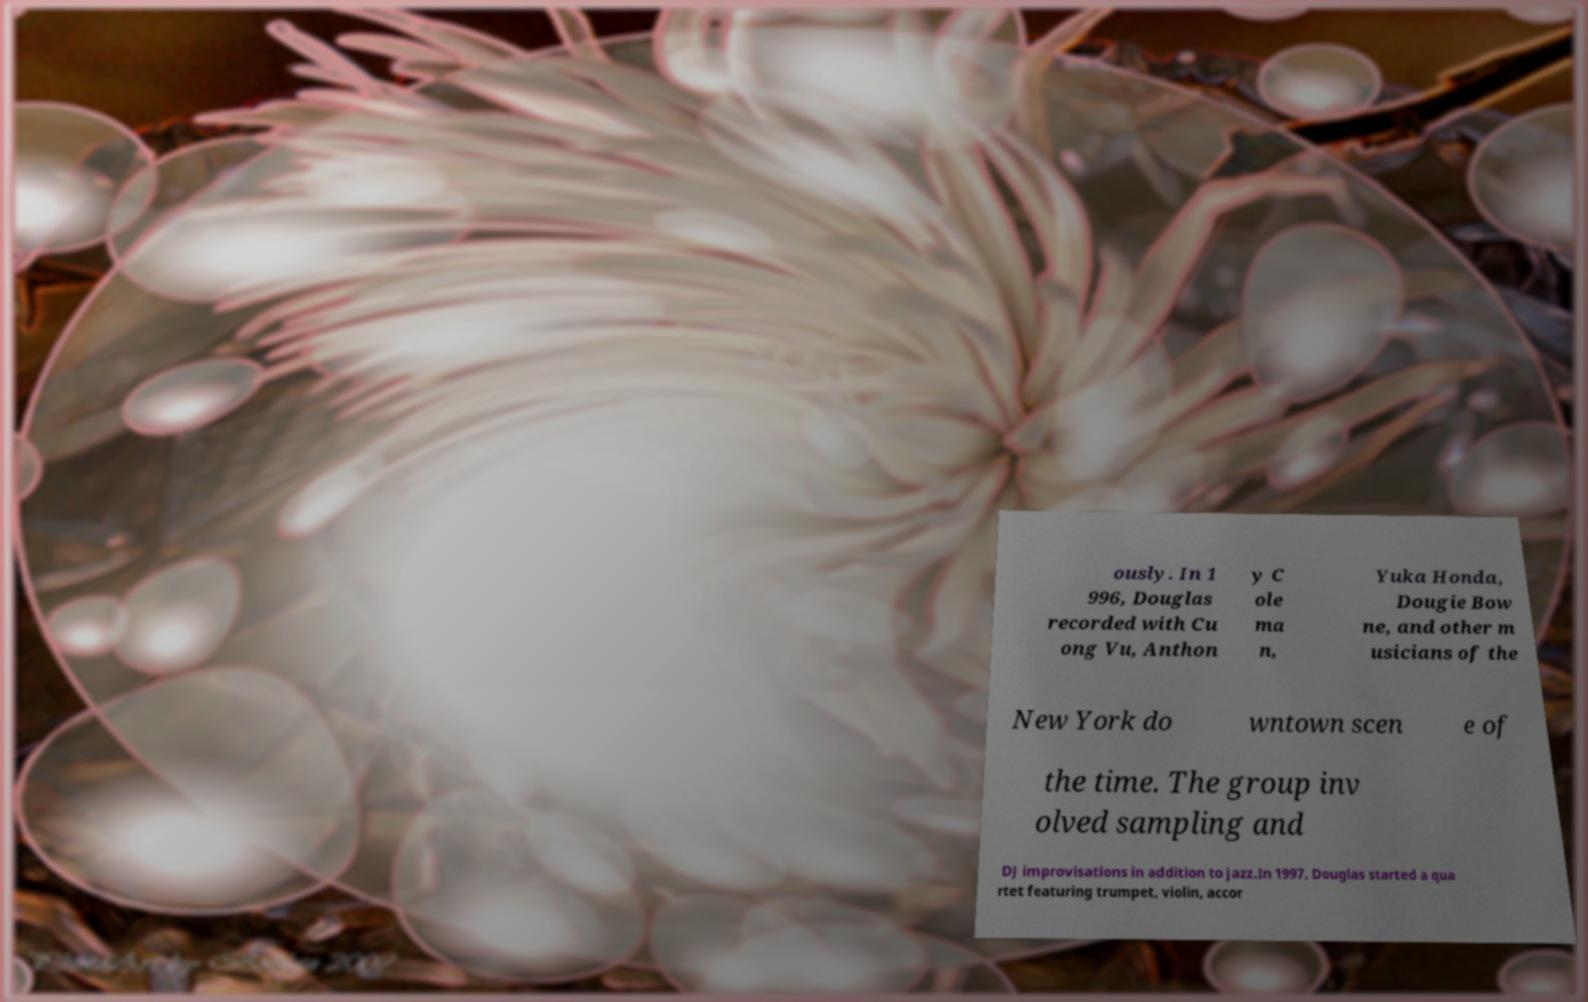For documentation purposes, I need the text within this image transcribed. Could you provide that? ously. In 1 996, Douglas recorded with Cu ong Vu, Anthon y C ole ma n, Yuka Honda, Dougie Bow ne, and other m usicians of the New York do wntown scen e of the time. The group inv olved sampling and DJ improvisations in addition to jazz.In 1997, Douglas started a qua rtet featuring trumpet, violin, accor 